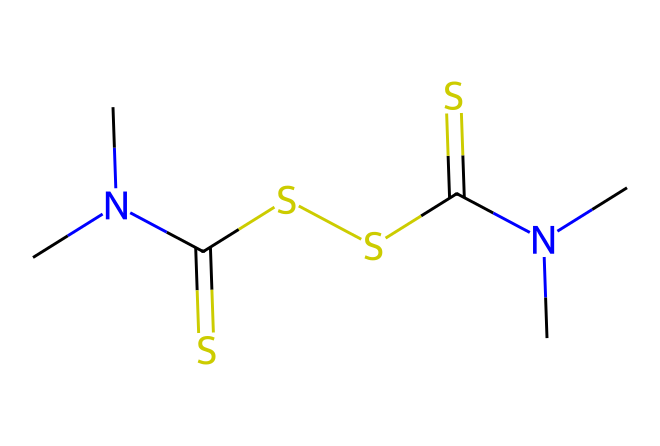What is the name of this chemical? The SMILES representation given corresponds to thiram, which is a known fungicide used in agriculture and in seed treatments. This can be inferred from the specific structure and functional groups present in the chemical.
Answer: thiram How many nitrogen atoms are in thiram? By analyzing the SMILES representation, you can identify the presence of nitrogen atoms. The structure shows two 'N' letters, indicating there are two nitrogen atoms in the molecule.
Answer: 2 What elements make up thiram? The chemical structure contains carbon (C), sulfur (S), and nitrogen (N) as evidenced by their respective symbols in the SMILES representation. Therefore, these are the elements that comprise thiram.
Answer: carbon, sulfur, nitrogen How many sulfur atoms are present in thiram? In the provided SMILES, there are two 'S' symbols, indicating the presence of two sulfur atoms in the molecular structure of thiram.
Answer: 2 What type of chemical is thiram classified as? Thiram belongs to the class of chemicals known as fungicides. Its structure and activity specifically identify it as a fungicide meant for inhibiting the growth of fungi.
Answer: fungicide What functional groups are present in thiram? The presence of thiocarbamate groups in thiram is indicated by the 'C(=S)' and 'N(C)C' notations in the SMILES. These groups are characteristic of its classification and function.
Answer: thiocarbamate What is the total number of carbon atoms in thiram? In examining the SMILES, you can count the 'C' symbols present. There are five 'C' symbols, indicating that there are five carbon atoms in the molecule.
Answer: 5 